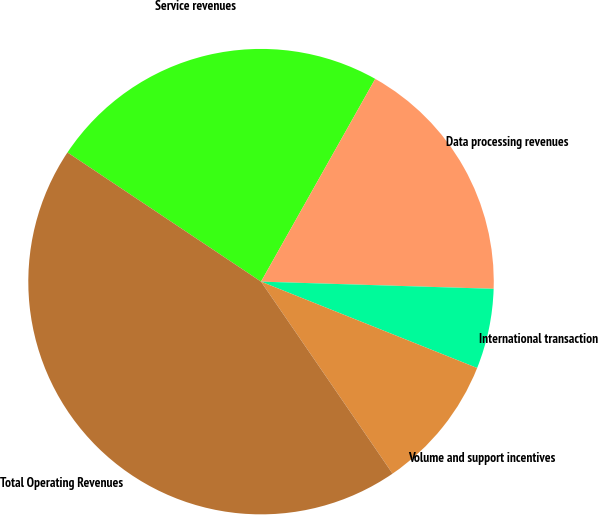Convert chart. <chart><loc_0><loc_0><loc_500><loc_500><pie_chart><fcel>Service revenues<fcel>Data processing revenues<fcel>International transaction<fcel>Volume and support incentives<fcel>Total Operating Revenues<nl><fcel>23.8%<fcel>17.33%<fcel>5.56%<fcel>9.39%<fcel>43.93%<nl></chart> 